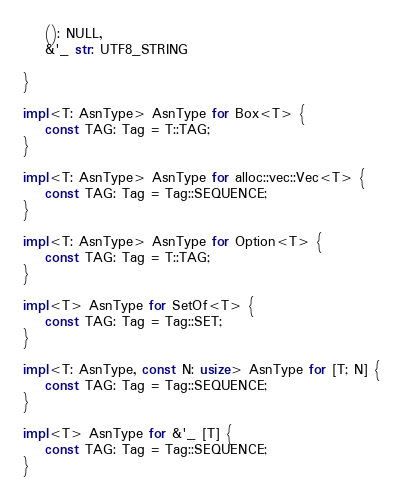Convert code to text. <code><loc_0><loc_0><loc_500><loc_500><_Rust_>    (): NULL,
    &'_ str: UTF8_STRING

}

impl<T: AsnType> AsnType for Box<T> {
    const TAG: Tag = T::TAG;
}

impl<T: AsnType> AsnType for alloc::vec::Vec<T> {
    const TAG: Tag = Tag::SEQUENCE;
}

impl<T: AsnType> AsnType for Option<T> {
    const TAG: Tag = T::TAG;
}

impl<T> AsnType for SetOf<T> {
    const TAG: Tag = Tag::SET;
}

impl<T: AsnType, const N: usize> AsnType for [T; N] {
    const TAG: Tag = Tag::SEQUENCE;
}

impl<T> AsnType for &'_ [T] {
    const TAG: Tag = Tag::SEQUENCE;
}
</code> 